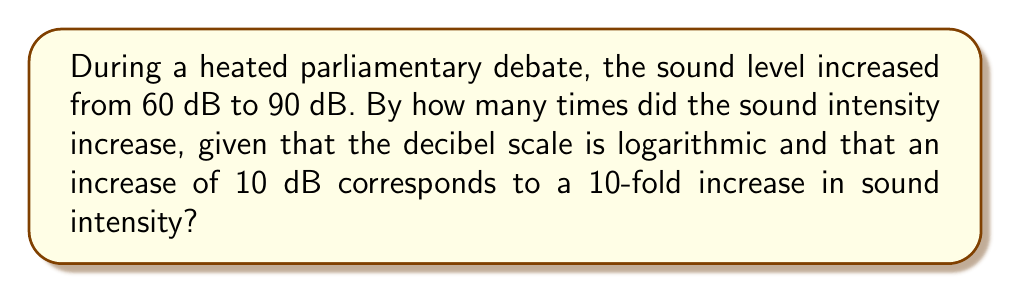Can you solve this math problem? Let's approach this step-by-step:

1) The decibel scale is logarithmic, and the relationship between decibels and intensity is given by:

   $$ L = 10 \log_{10}\left(\frac{I}{I_0}\right) $$

   where $L$ is the sound level in decibels, $I$ is the sound intensity, and $I_0$ is a reference intensity.

2) We're told that an increase of 10 dB corresponds to a 10-fold increase in intensity. This means:

   $$ 10 \text{ dB} = 10 \log_{10}(10) $$

3) In our case, the increase is 30 dB (from 60 dB to 90 dB). Let's call the factor of increase $x$. We can set up the equation:

   $$ 30 = 10 \log_{10}(x) $$

4) Solving for $x$:

   $$ 3 = \log_{10}(x) $$
   $$ 10^3 = x $$
   $$ x = 1000 $$

5) Therefore, the sound intensity increased by a factor of 1000.

This means that the sound intensity in the parliament became 1000 times stronger during the heated debate, which is quite significant and likely made it difficult for our fellow politicians to hear each other!
Answer: 1000 times 